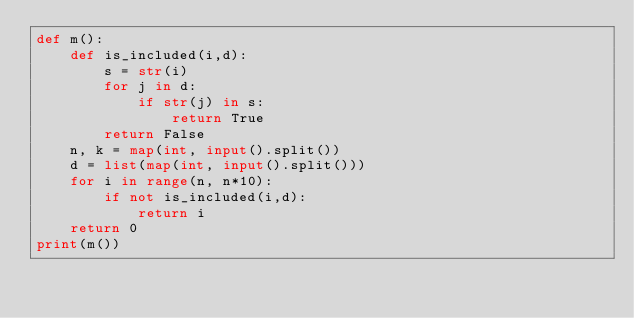<code> <loc_0><loc_0><loc_500><loc_500><_Python_>def m():
    def is_included(i,d):
        s = str(i)
        for j in d:
            if str(j) in s:
                return True
        return False
    n, k = map(int, input().split())
    d = list(map(int, input().split()))
    for i in range(n, n*10):
        if not is_included(i,d):
            return i
    return 0
print(m())</code> 